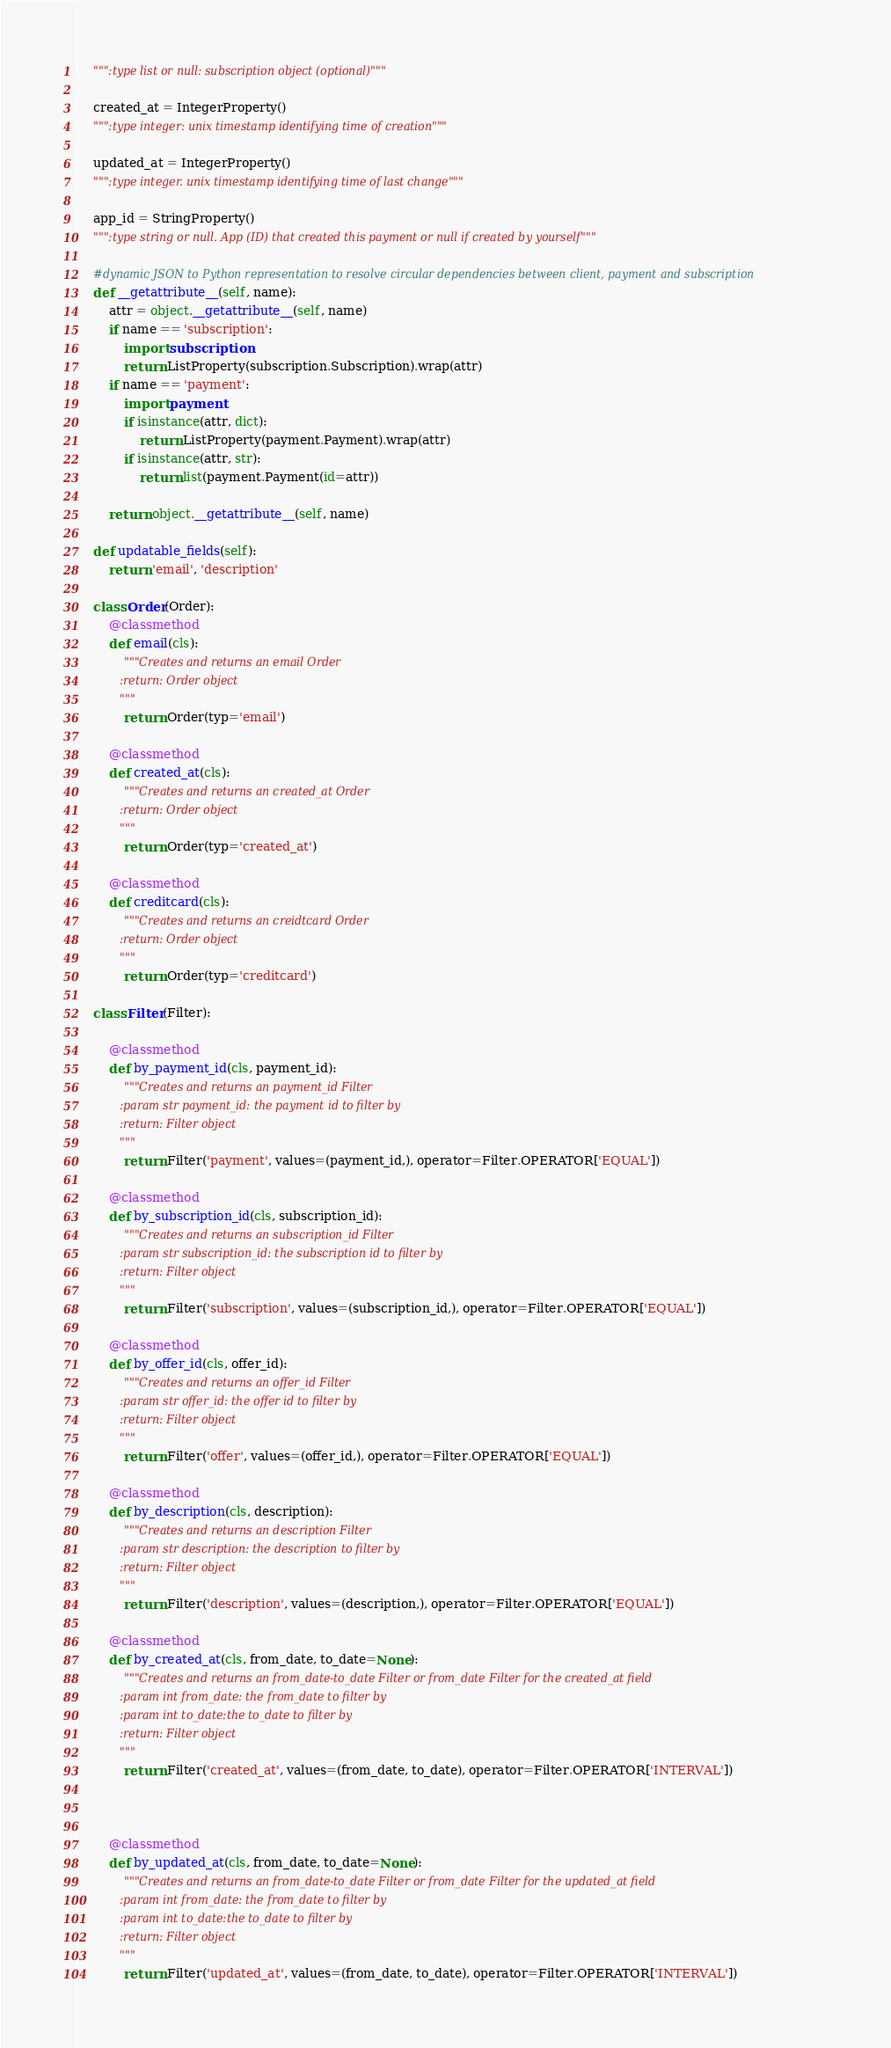<code> <loc_0><loc_0><loc_500><loc_500><_Python_>    """:type list or null: subscription object (optional)"""

    created_at = IntegerProperty()
    """:type integer: unix timestamp identifying time of creation"""

    updated_at = IntegerProperty()
    """:type integer. unix timestamp identifying time of last change"""

    app_id = StringProperty()
    """:type string or null. App (ID) that created this payment or null if created by yourself"""

    #dynamic JSON to Python representation to resolve circular dependencies between client, payment and subscription
    def __getattribute__(self, name):
        attr = object.__getattribute__(self, name)
        if name == 'subscription':
            import subscription
            return ListProperty(subscription.Subscription).wrap(attr)
        if name == 'payment':
            import payment
            if isinstance(attr, dict):
                return ListProperty(payment.Payment).wrap(attr)
            if isinstance(attr, str):
                return list(payment.Payment(id=attr))

        return object.__getattribute__(self, name)

    def updatable_fields(self):
        return 'email', 'description'

    class Order(Order):
        @classmethod
        def email(cls):
            """Creates and returns an email Order
            :return: Order object
            """
            return Order(typ='email')

        @classmethod
        def created_at(cls):
            """Creates and returns an created_at Order
            :return: Order object
            """
            return Order(typ='created_at')

        @classmethod
        def creditcard(cls):
            """Creates and returns an creidtcard Order
            :return: Order object
            """
            return Order(typ='creditcard')

    class Filter(Filter):

        @classmethod
        def by_payment_id(cls, payment_id):
            """Creates and returns an payment_id Filter
            :param str payment_id: the payment id to filter by
            :return: Filter object
            """
            return Filter('payment', values=(payment_id,), operator=Filter.OPERATOR['EQUAL'])

        @classmethod
        def by_subscription_id(cls, subscription_id):
            """Creates and returns an subscription_id Filter
            :param str subscription_id: the subscription id to filter by
            :return: Filter object
            """
            return Filter('subscription', values=(subscription_id,), operator=Filter.OPERATOR['EQUAL'])

        @classmethod
        def by_offer_id(cls, offer_id):
            """Creates and returns an offer_id Filter
            :param str offer_id: the offer id to filter by
            :return: Filter object
            """
            return Filter('offer', values=(offer_id,), operator=Filter.OPERATOR['EQUAL'])

        @classmethod
        def by_description(cls, description):
            """Creates and returns an description Filter
            :param str description: the description to filter by
            :return: Filter object
            """
            return Filter('description', values=(description,), operator=Filter.OPERATOR['EQUAL'])

        @classmethod
        def by_created_at(cls, from_date, to_date=None):
            """Creates and returns an from_date-to_date Filter or from_date Filter for the created_at field
            :param int from_date: the from_date to filter by
            :param int to_date:the to_date to filter by
            :return: Filter object
            """
            return Filter('created_at', values=(from_date, to_date), operator=Filter.OPERATOR['INTERVAL'])



        @classmethod
        def by_updated_at(cls, from_date, to_date=None):
            """Creates and returns an from_date-to_date Filter or from_date Filter for the updated_at field
            :param int from_date: the from_date to filter by
            :param int to_date:the to_date to filter by
            :return: Filter object
            """
            return Filter('updated_at', values=(from_date, to_date), operator=Filter.OPERATOR['INTERVAL'])</code> 